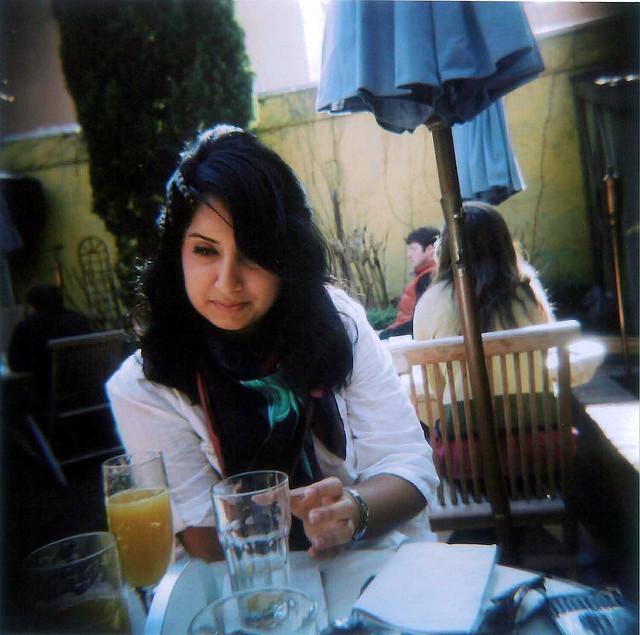How many umbrellas can you see?
Give a very brief answer. 2. How many cups are there?
Give a very brief answer. 4. How many people are in the picture?
Give a very brief answer. 4. How many dining tables can you see?
Give a very brief answer. 2. How many chairs are there?
Give a very brief answer. 2. How many people are on the boat not at the dock?
Give a very brief answer. 0. 